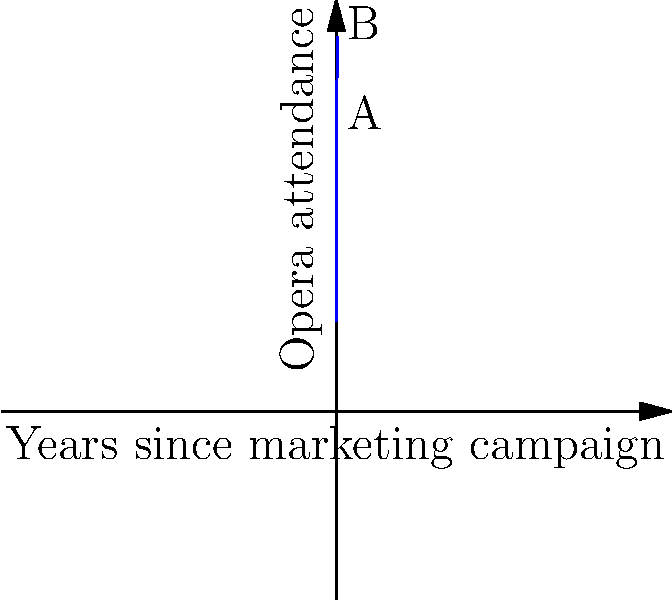The graph shows the attendance at a local opera house over time following a new marketing campaign. Point A represents attendance after 5 years, and point B represents attendance after 10 years. If this trend continues, what will be the approximate change in attendance between years 10 and 15? To solve this problem, we need to analyze the growth curve and estimate the change in attendance over time. Let's approach this step-by-step:

1. Observe the curve: The graph shows a parabolic curve that increases initially and then starts to decrease.

2. Identify key points:
   - Point A (5 years): Peak of the curve
   - Point B (10 years): On the decreasing part of the curve

3. Estimate the attendance at key points:
   - Year 10 (Point B): Approximately 3000 attendees
   - Year 15: We need to estimate this based on the curve's trajectory

4. Analyze the curve's behavior:
   - The decrease from year 5 to year 10 is steeper than from year 0 to year 5
   - This suggests the rate of decrease is accelerating

5. Estimate attendance at year 15:
   - Given the accelerating decrease, we can estimate the attendance at year 15 to be around 1500

6. Calculate the change in attendance:
   Change = Attendance at year 15 - Attendance at year 10
   $\approx 1500 - 3000 = -1500$

The negative value indicates a decrease in attendance.
Answer: $-1500$ attendees 